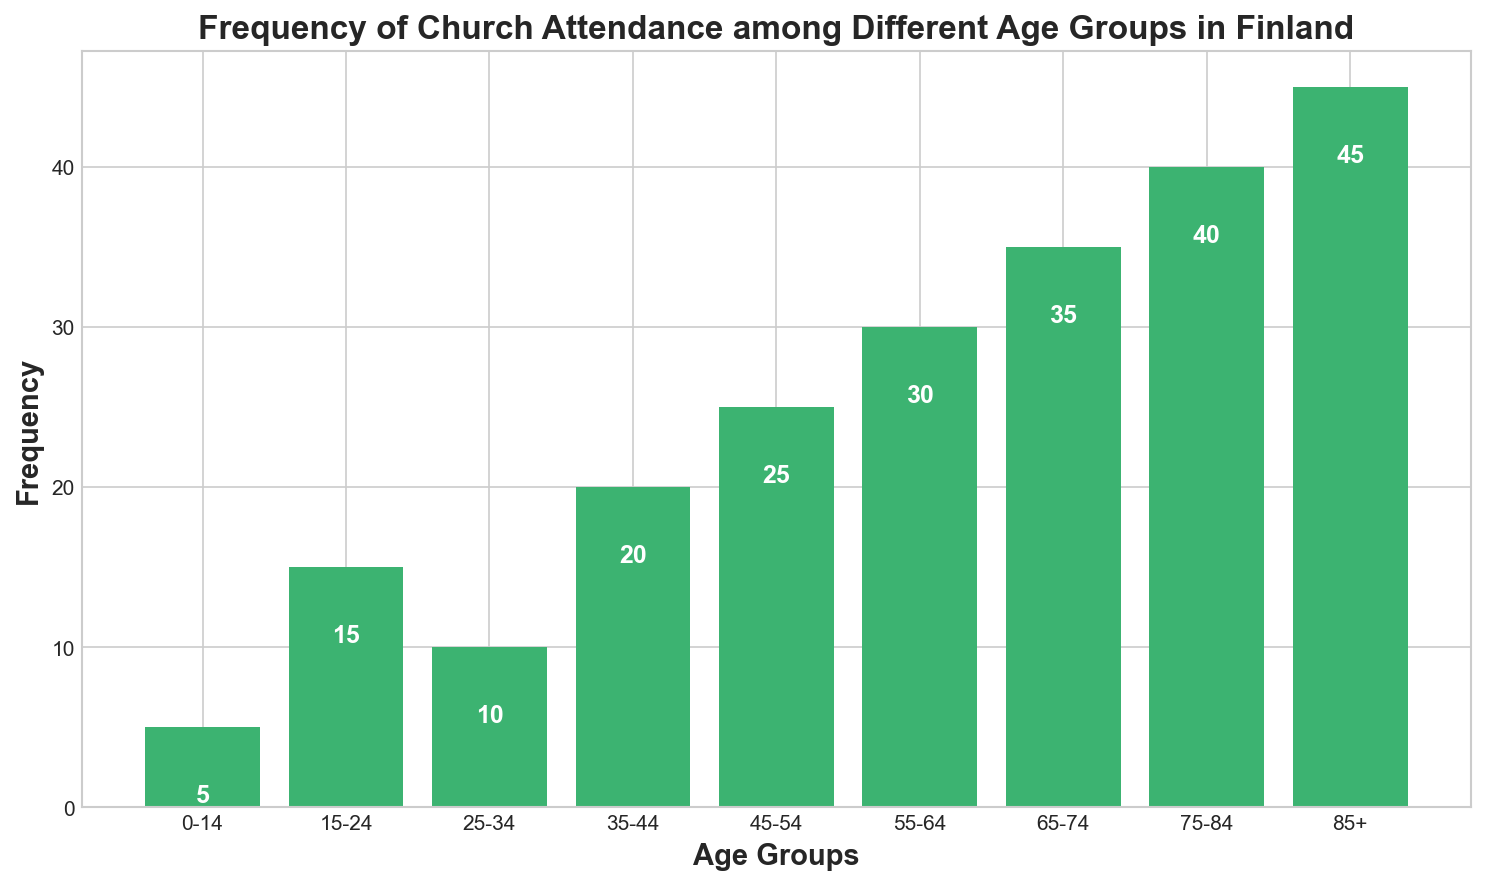Which age group has the highest frequency of church attendance? The highest bar in the chart corresponds to the "85+" age group, indicating that this age group has the highest frequency of church attendance.
Answer: 85+ What is the frequency of church attendance for the 55-64 age group? The bar for the 55-64 age group shows a height of 30.
Answer: 30 Which age group has a lower frequency of church attendance: 25-34 or 35-44? Comparing the heights of the bars, the 25-34 age group has a lower frequency (10) than the 35-44 age group (20).
Answer: 25-34 What is the difference in church attendance frequency between the 75-84 and 85+ age groups? By subtracting the frequency of the 75-84 age group (40) from that of the 85+ age group (45), we get 45 - 40.
Answer: 5 What is the total frequency of church attendance among all age groups combined? Summing up all the frequencies: 5 + 15 + 10 + 20 + 25 + 30 + 35 + 40 + 45.
Answer: 225 Which age group has a higher attendance frequency: 45-54 or 55-64? The bar representing the 55-64 age group (frequency 30) is taller than that representing the 45-54 age group (frequency 25).
Answer: 55-64 What is the median frequency of church attendance among the age groups? Organizing the frequencies in ascending order: 5, 10, 15, 20, 25, 30, 35, 40, 45. The median value, being the middle one, is the fifth value: 25.
Answer: 25 Which two consecutive age groups show the largest increase in church attendance frequency? By comparing the differences between consecutive frequencies: 
15-24 to 25-34: -5 
25-34 to 35-44: +10 
35-44 to 45-54: +5 
45-54 to 55-64: +5 
55-64 to 65-74: +5 
65-74 to 75-84: +5 
75-84 to 85+: +5
The largest increase of +10 is from the 25-34 to 35-44 group.
Answer: 25-34 to 35-44 